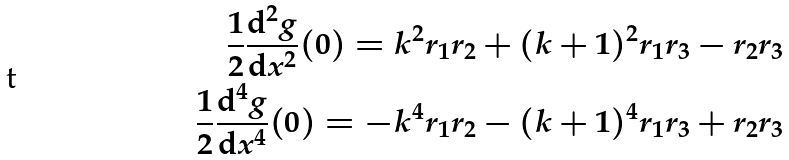Convert formula to latex. <formula><loc_0><loc_0><loc_500><loc_500>\frac { 1 } { 2 } \frac { \mathrm d ^ { 2 } { g } } { \mathrm d x ^ { 2 } } ( 0 ) = k ^ { 2 } r _ { 1 } r _ { 2 } + ( k + 1 ) ^ { 2 } r _ { 1 } r _ { 3 } - r _ { 2 } r _ { 3 } \\ \frac { 1 } { 2 } \frac { \mathrm d ^ { 4 } { g } } { \mathrm d x ^ { 4 } } ( 0 ) = - k ^ { 4 } r _ { 1 } r _ { 2 } - ( k + 1 ) ^ { 4 } r _ { 1 } r _ { 3 } + r _ { 2 } r _ { 3 }</formula> 